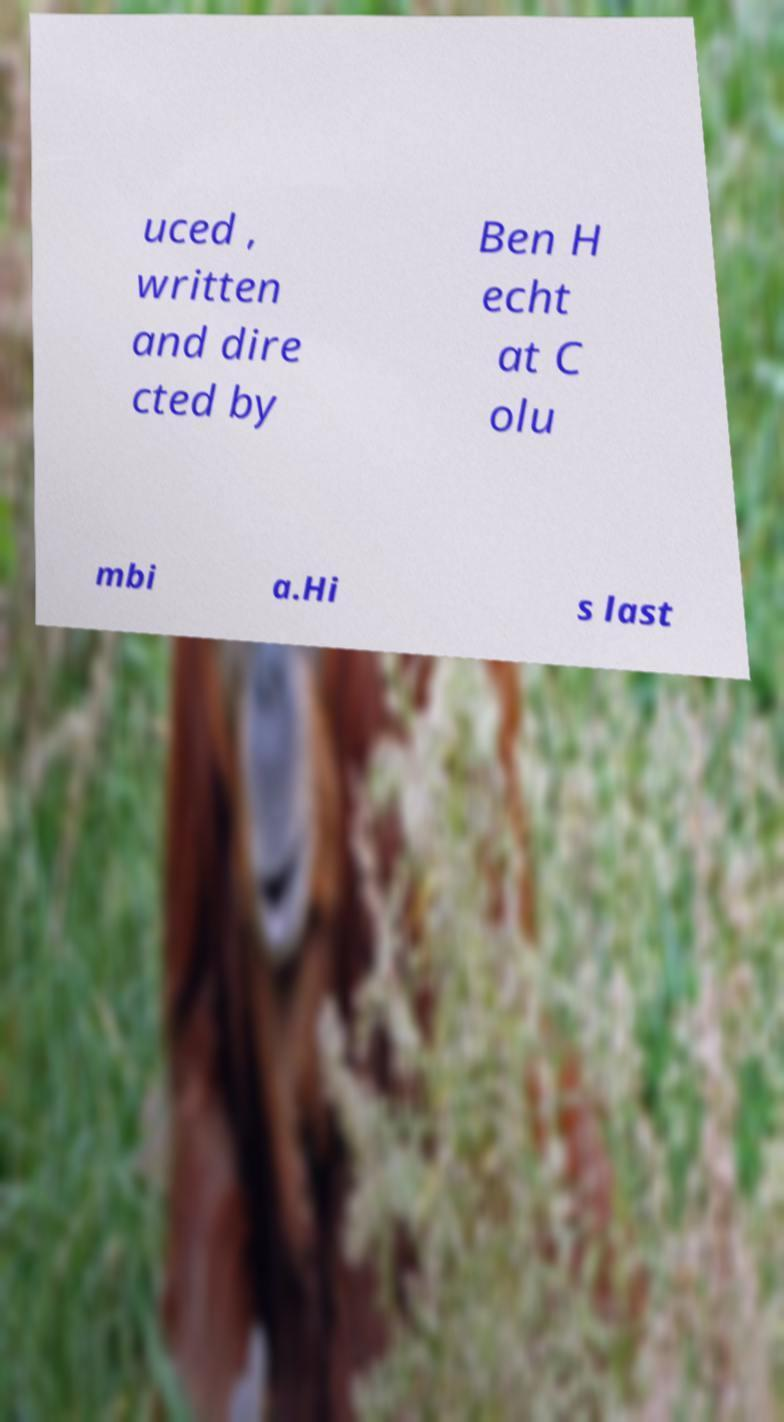For documentation purposes, I need the text within this image transcribed. Could you provide that? uced , written and dire cted by Ben H echt at C olu mbi a.Hi s last 